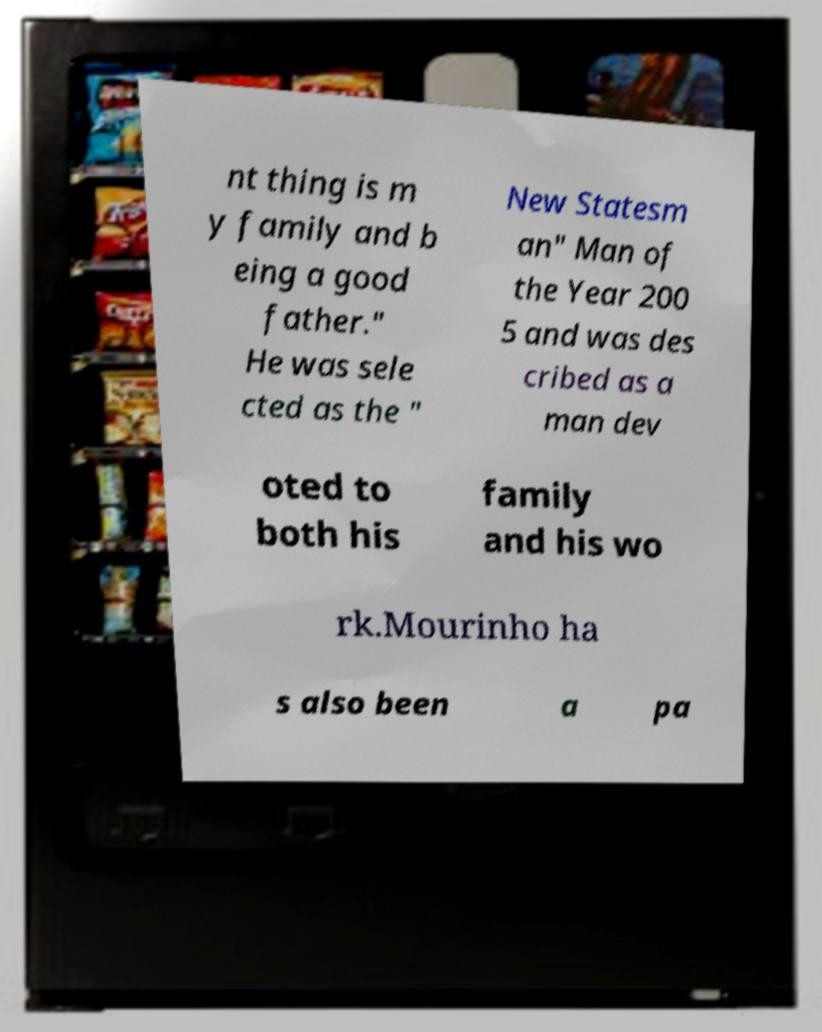Can you accurately transcribe the text from the provided image for me? nt thing is m y family and b eing a good father." He was sele cted as the " New Statesm an" Man of the Year 200 5 and was des cribed as a man dev oted to both his family and his wo rk.Mourinho ha s also been a pa 